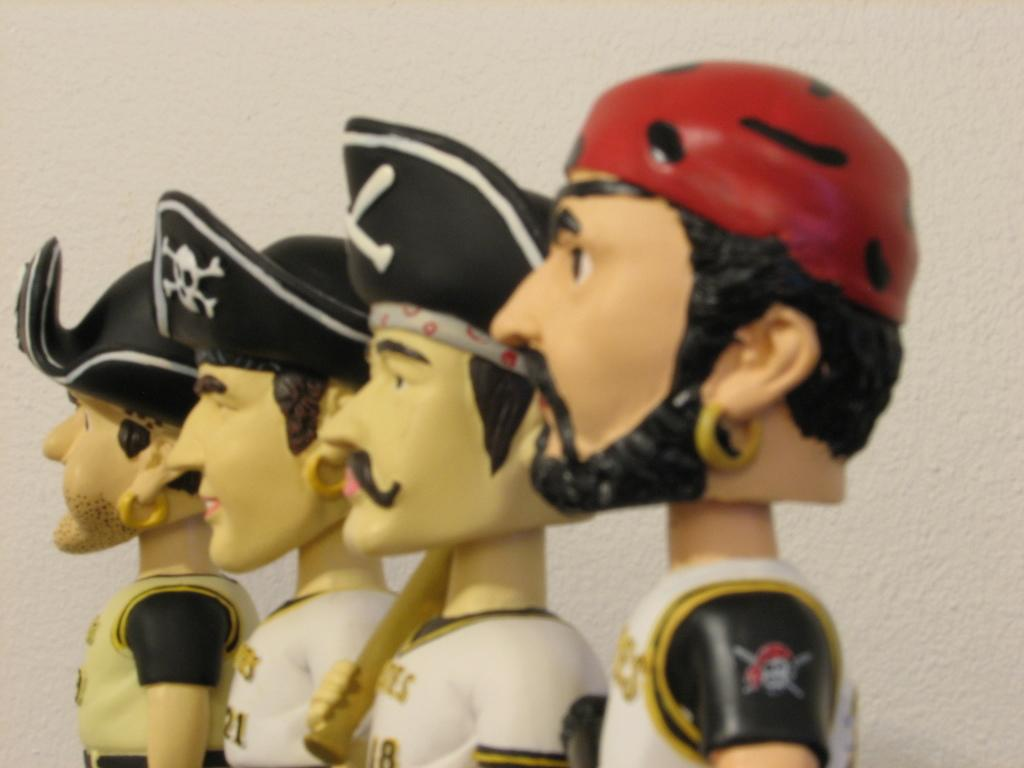What objects are present in the image? There are toys in the image. What can be seen in the background of the image? There is a wall in the background of the image. What rule is being enforced by the wren in the image? There is no wren present in the image, and therefore no rule enforcement can be observed. What is the hammer being used for in the image? There is no hammer present in the image, so its use cannot be determined. 